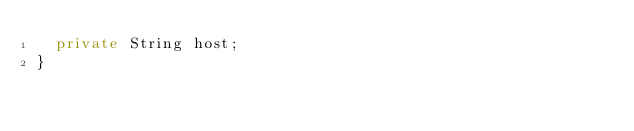<code> <loc_0><loc_0><loc_500><loc_500><_Java_>	private String host;
}
</code> 